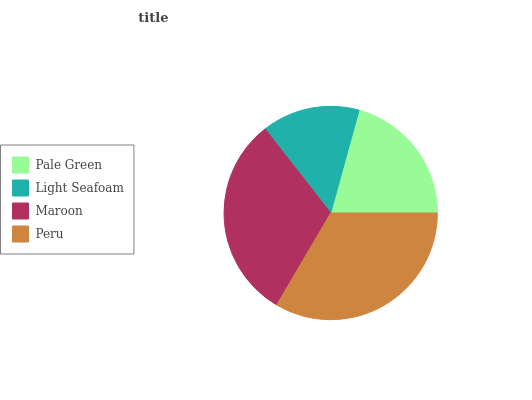Is Light Seafoam the minimum?
Answer yes or no. Yes. Is Peru the maximum?
Answer yes or no. Yes. Is Maroon the minimum?
Answer yes or no. No. Is Maroon the maximum?
Answer yes or no. No. Is Maroon greater than Light Seafoam?
Answer yes or no. Yes. Is Light Seafoam less than Maroon?
Answer yes or no. Yes. Is Light Seafoam greater than Maroon?
Answer yes or no. No. Is Maroon less than Light Seafoam?
Answer yes or no. No. Is Maroon the high median?
Answer yes or no. Yes. Is Pale Green the low median?
Answer yes or no. Yes. Is Light Seafoam the high median?
Answer yes or no. No. Is Maroon the low median?
Answer yes or no. No. 